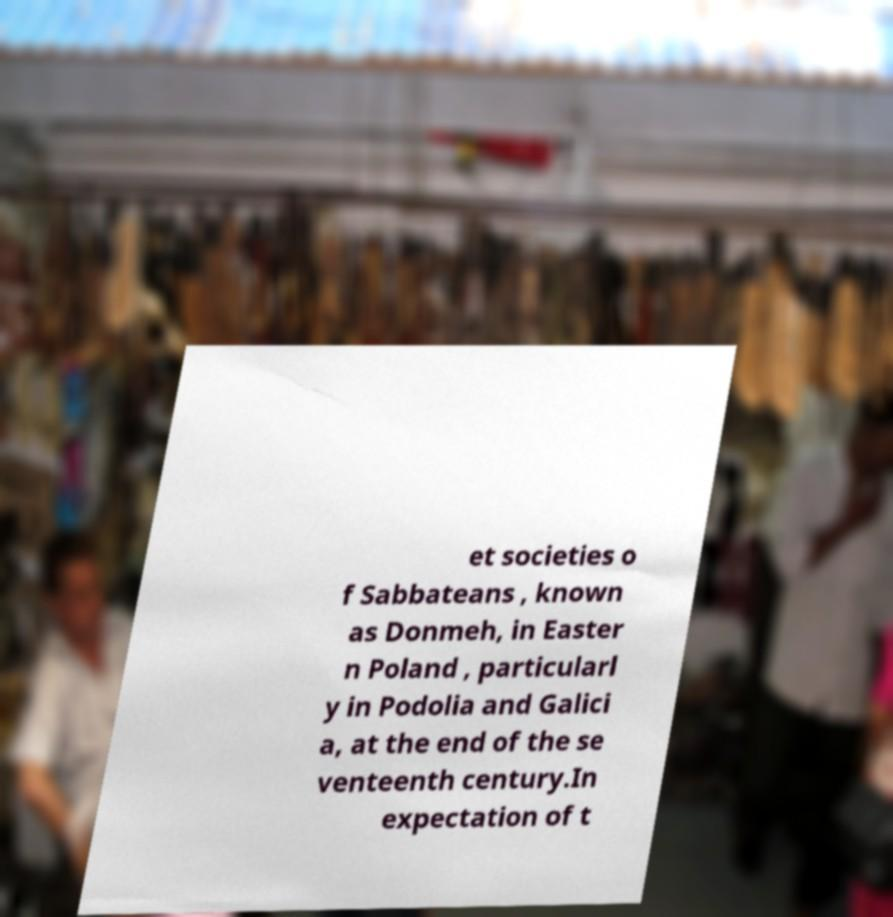Please identify and transcribe the text found in this image. et societies o f Sabbateans , known as Donmeh, in Easter n Poland , particularl y in Podolia and Galici a, at the end of the se venteenth century.In expectation of t 